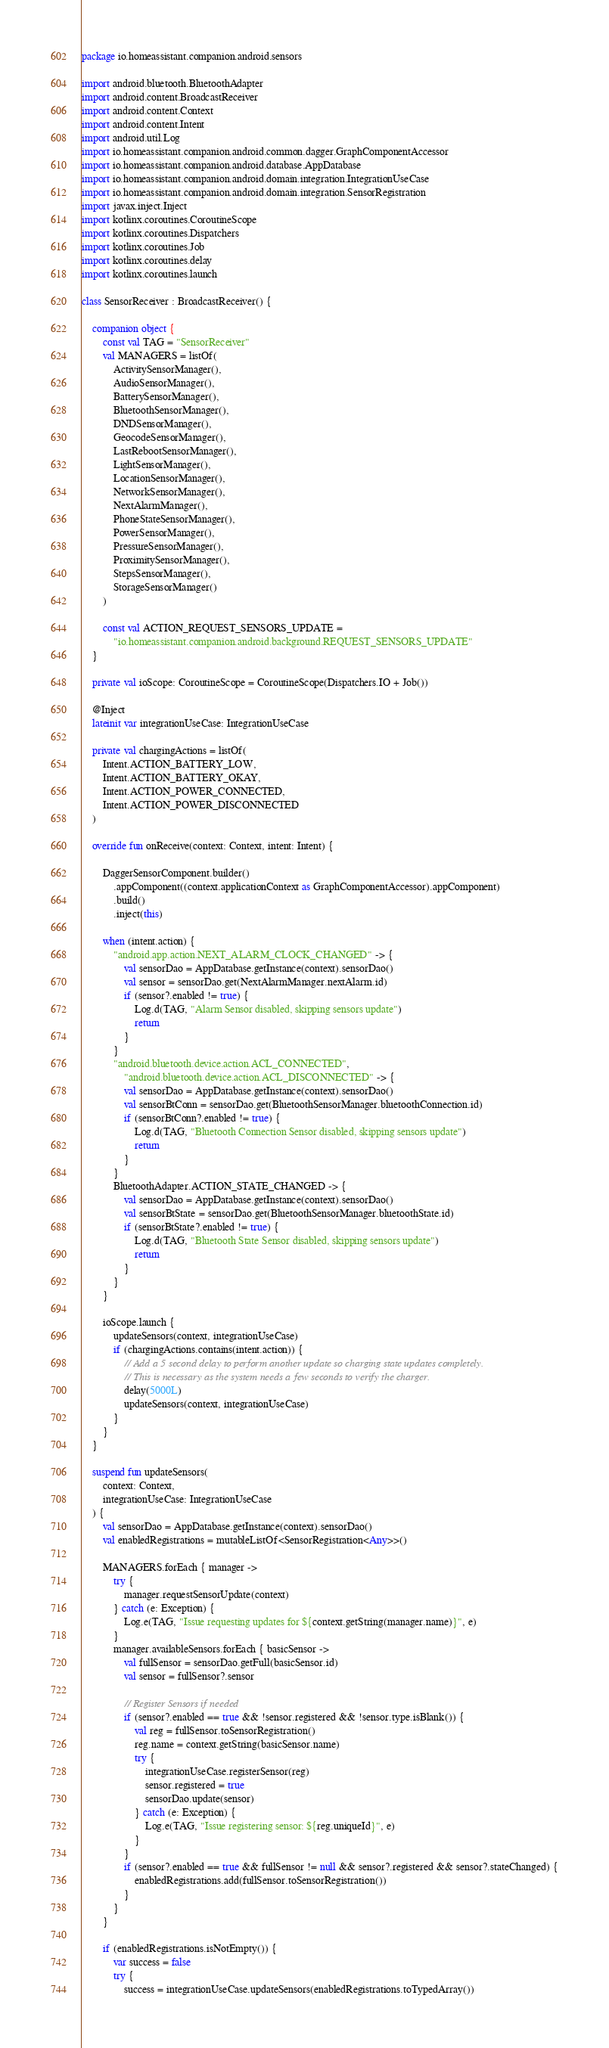<code> <loc_0><loc_0><loc_500><loc_500><_Kotlin_>package io.homeassistant.companion.android.sensors

import android.bluetooth.BluetoothAdapter
import android.content.BroadcastReceiver
import android.content.Context
import android.content.Intent
import android.util.Log
import io.homeassistant.companion.android.common.dagger.GraphComponentAccessor
import io.homeassistant.companion.android.database.AppDatabase
import io.homeassistant.companion.android.domain.integration.IntegrationUseCase
import io.homeassistant.companion.android.domain.integration.SensorRegistration
import javax.inject.Inject
import kotlinx.coroutines.CoroutineScope
import kotlinx.coroutines.Dispatchers
import kotlinx.coroutines.Job
import kotlinx.coroutines.delay
import kotlinx.coroutines.launch

class SensorReceiver : BroadcastReceiver() {

    companion object {
        const val TAG = "SensorReceiver"
        val MANAGERS = listOf(
            ActivitySensorManager(),
            AudioSensorManager(),
            BatterySensorManager(),
            BluetoothSensorManager(),
            DNDSensorManager(),
            GeocodeSensorManager(),
            LastRebootSensorManager(),
            LightSensorManager(),
            LocationSensorManager(),
            NetworkSensorManager(),
            NextAlarmManager(),
            PhoneStateSensorManager(),
            PowerSensorManager(),
            PressureSensorManager(),
            ProximitySensorManager(),
            StepsSensorManager(),
            StorageSensorManager()
        )

        const val ACTION_REQUEST_SENSORS_UPDATE =
            "io.homeassistant.companion.android.background.REQUEST_SENSORS_UPDATE"
    }

    private val ioScope: CoroutineScope = CoroutineScope(Dispatchers.IO + Job())

    @Inject
    lateinit var integrationUseCase: IntegrationUseCase

    private val chargingActions = listOf(
        Intent.ACTION_BATTERY_LOW,
        Intent.ACTION_BATTERY_OKAY,
        Intent.ACTION_POWER_CONNECTED,
        Intent.ACTION_POWER_DISCONNECTED
    )

    override fun onReceive(context: Context, intent: Intent) {

        DaggerSensorComponent.builder()
            .appComponent((context.applicationContext as GraphComponentAccessor).appComponent)
            .build()
            .inject(this)

        when (intent.action) {
            "android.app.action.NEXT_ALARM_CLOCK_CHANGED" -> {
                val sensorDao = AppDatabase.getInstance(context).sensorDao()
                val sensor = sensorDao.get(NextAlarmManager.nextAlarm.id)
                if (sensor?.enabled != true) {
                    Log.d(TAG, "Alarm Sensor disabled, skipping sensors update")
                    return
                }
            }
            "android.bluetooth.device.action.ACL_CONNECTED",
                "android.bluetooth.device.action.ACL_DISCONNECTED" -> {
                val sensorDao = AppDatabase.getInstance(context).sensorDao()
                val sensorBtConn = sensorDao.get(BluetoothSensorManager.bluetoothConnection.id)
                if (sensorBtConn?.enabled != true) {
                    Log.d(TAG, "Bluetooth Connection Sensor disabled, skipping sensors update")
                    return
                }
            }
            BluetoothAdapter.ACTION_STATE_CHANGED -> {
                val sensorDao = AppDatabase.getInstance(context).sensorDao()
                val sensorBtState = sensorDao.get(BluetoothSensorManager.bluetoothState.id)
                if (sensorBtState?.enabled != true) {
                    Log.d(TAG, "Bluetooth State Sensor disabled, skipping sensors update")
                    return
                }
            }
        }

        ioScope.launch {
            updateSensors(context, integrationUseCase)
            if (chargingActions.contains(intent.action)) {
                // Add a 5 second delay to perform another update so charging state updates completely.
                // This is necessary as the system needs a few seconds to verify the charger.
                delay(5000L)
                updateSensors(context, integrationUseCase)
            }
        }
    }

    suspend fun updateSensors(
        context: Context,
        integrationUseCase: IntegrationUseCase
    ) {
        val sensorDao = AppDatabase.getInstance(context).sensorDao()
        val enabledRegistrations = mutableListOf<SensorRegistration<Any>>()

        MANAGERS.forEach { manager ->
            try {
                manager.requestSensorUpdate(context)
            } catch (e: Exception) {
                Log.e(TAG, "Issue requesting updates for ${context.getString(manager.name)}", e)
            }
            manager.availableSensors.forEach { basicSensor ->
                val fullSensor = sensorDao.getFull(basicSensor.id)
                val sensor = fullSensor?.sensor

                // Register Sensors if needed
                if (sensor?.enabled == true && !sensor.registered && !sensor.type.isBlank()) {
                    val reg = fullSensor.toSensorRegistration()
                    reg.name = context.getString(basicSensor.name)
                    try {
                        integrationUseCase.registerSensor(reg)
                        sensor.registered = true
                        sensorDao.update(sensor)
                    } catch (e: Exception) {
                        Log.e(TAG, "Issue registering sensor: ${reg.uniqueId}", e)
                    }
                }
                if (sensor?.enabled == true && fullSensor != null && sensor?.registered && sensor?.stateChanged) {
                    enabledRegistrations.add(fullSensor.toSensorRegistration())
                }
            }
        }

        if (enabledRegistrations.isNotEmpty()) {
            var success = false
            try {
                success = integrationUseCase.updateSensors(enabledRegistrations.toTypedArray())</code> 